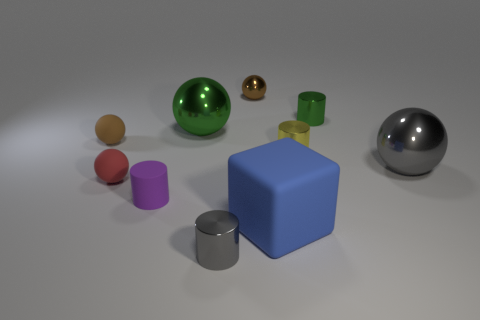Subtract all green balls. How many balls are left? 4 Subtract all gray metal cylinders. How many cylinders are left? 3 Subtract all red cylinders. Subtract all green balls. How many cylinders are left? 4 Subtract all cylinders. How many objects are left? 6 Add 5 big rubber blocks. How many big rubber blocks exist? 6 Subtract 0 gray cubes. How many objects are left? 10 Subtract all big purple metal objects. Subtract all gray metallic objects. How many objects are left? 8 Add 2 small gray objects. How many small gray objects are left? 3 